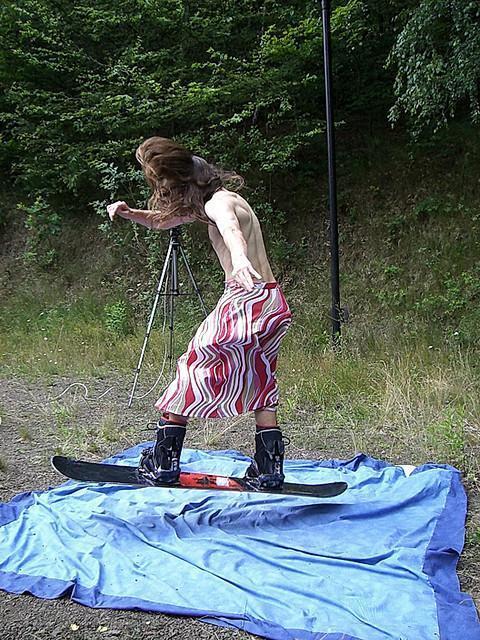How many elephants have 2 people riding them?
Give a very brief answer. 0. 